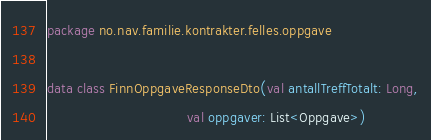Convert code to text. <code><loc_0><loc_0><loc_500><loc_500><_Kotlin_>package no.nav.familie.kontrakter.felles.oppgave

data class FinnOppgaveResponseDto(val antallTreffTotalt: Long,
                                  val oppgaver: List<Oppgave>)</code> 